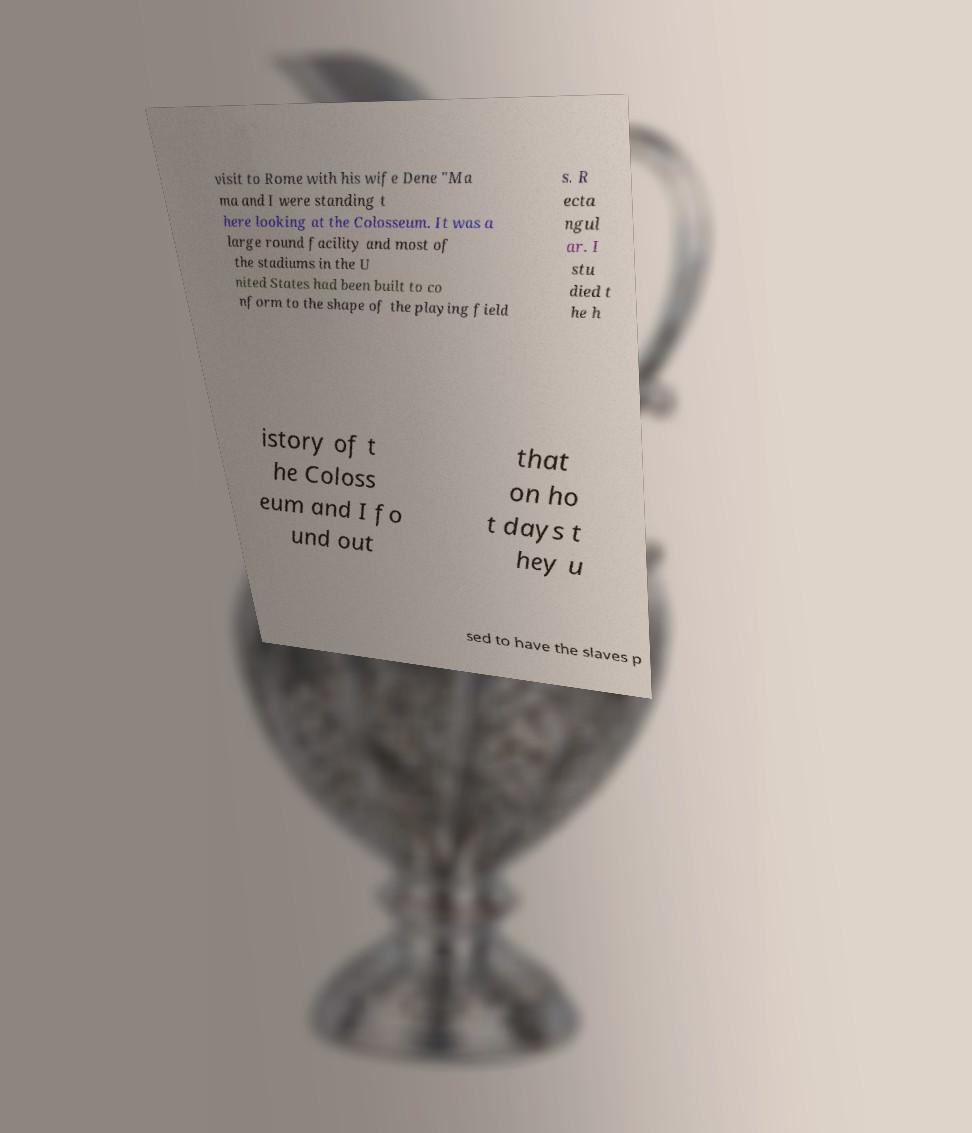Could you assist in decoding the text presented in this image and type it out clearly? visit to Rome with his wife Dene "Ma ma and I were standing t here looking at the Colosseum. It was a large round facility and most of the stadiums in the U nited States had been built to co nform to the shape of the playing field s. R ecta ngul ar. I stu died t he h istory of t he Coloss eum and I fo und out that on ho t days t hey u sed to have the slaves p 